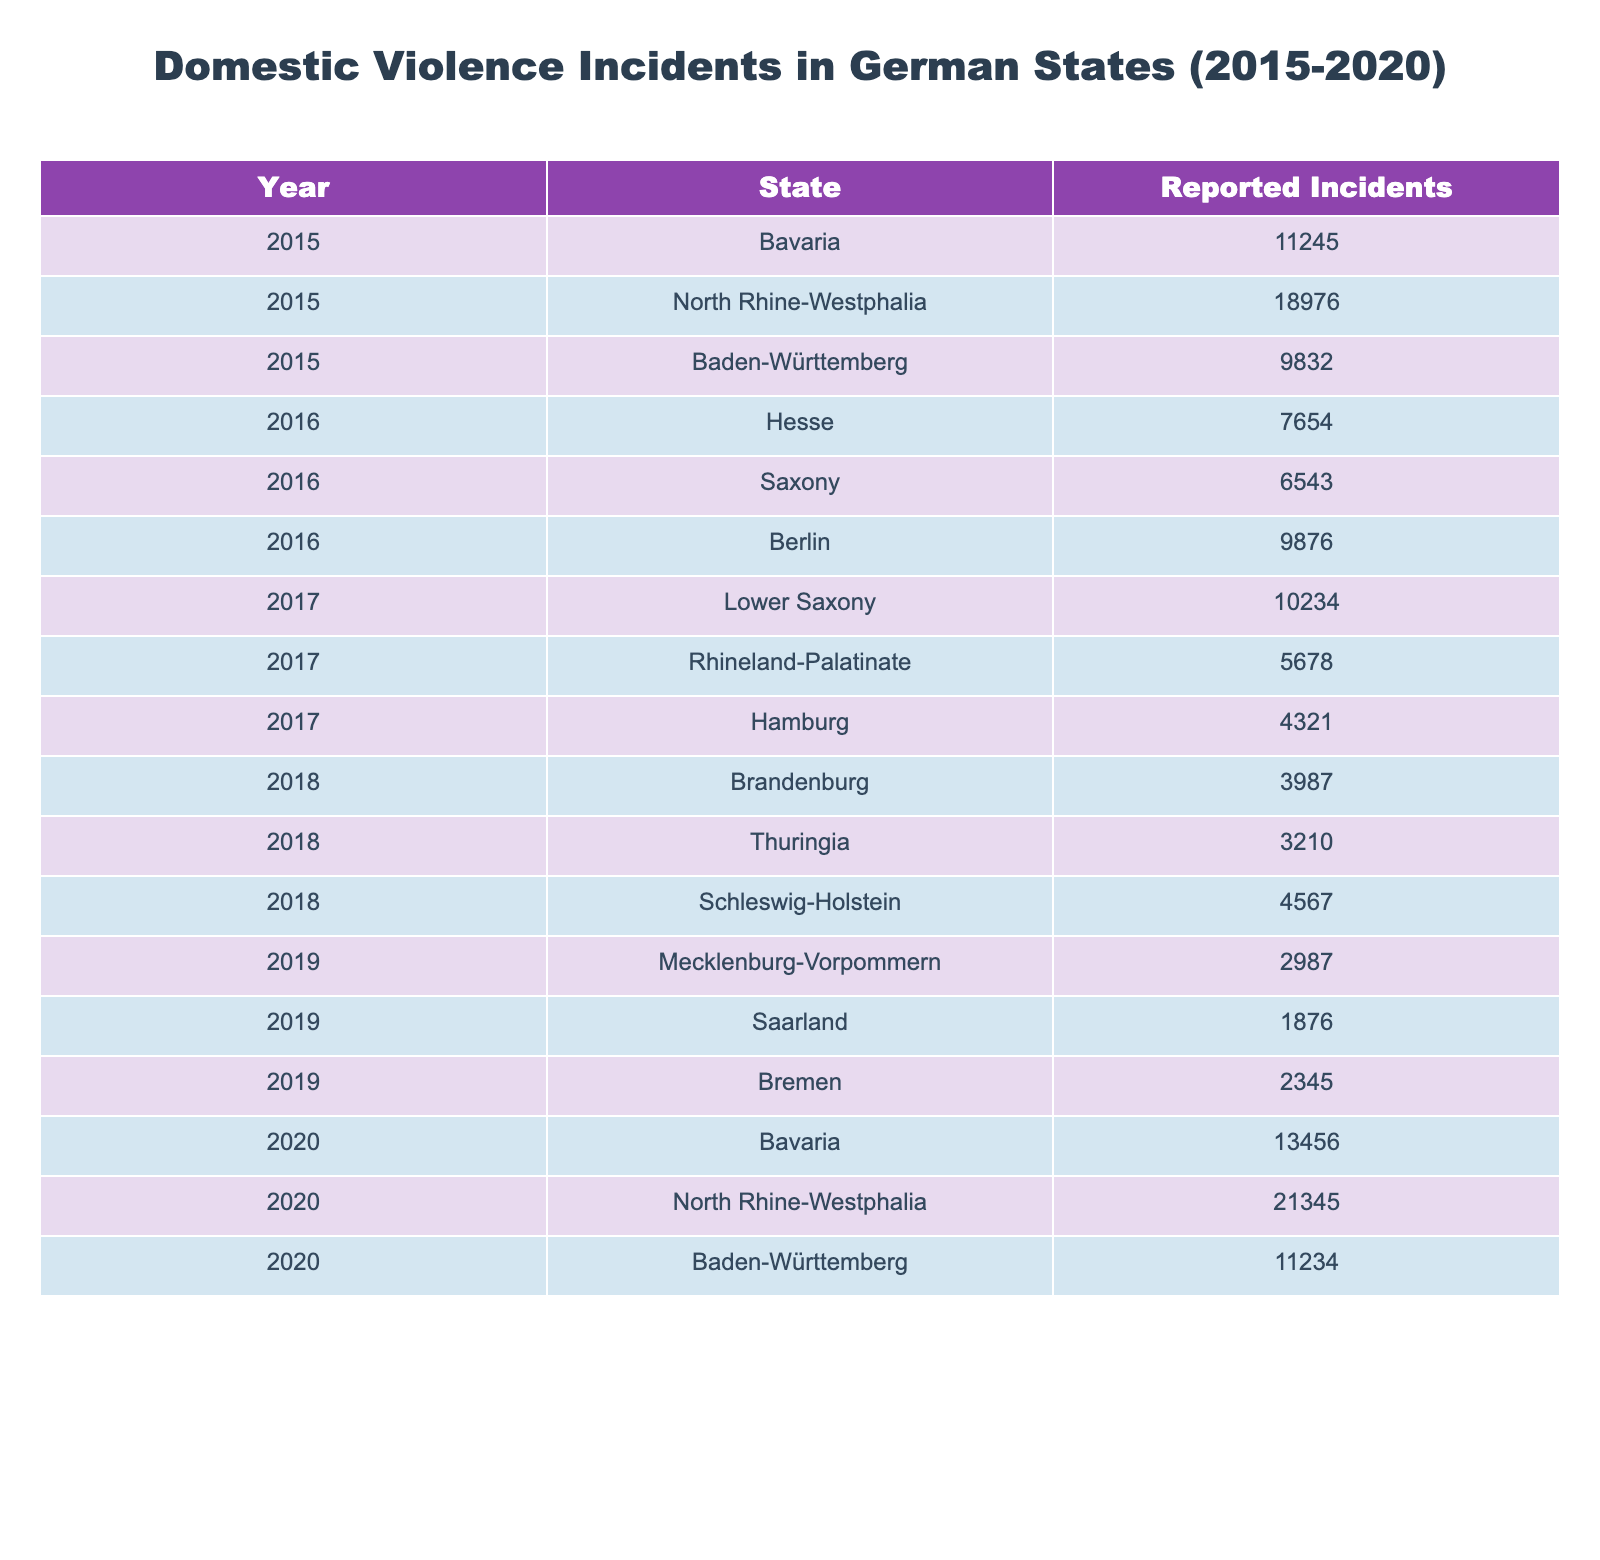What state had the highest reported incidents in 2020? In 2020, North Rhine-Westphalia had the highest number of reported incidents, with 21,345 incidents listed in the table.
Answer: North Rhine-Westphalia How many reported incidents were recorded in Bavaria in 2015 and 2020 combined? In 2015, Bavaria had 11,245 incidents and in 2020, it had 13,456 incidents. Combining these, we get 11,245 + 13,456 = 24,701.
Answer: 24,701 What is the average number of reported incidents across all states in 2016? The reported incidents in 2016 are: Hesse (7,654), Saxony (6,543), and Berlin (9,876). The sum is 7,654 + 6,543 + 9,876 = 24,073, and there are 3 states, so the average is 24,073 / 3 = 8,024.33, which rounds to approximately 8,024.
Answer: Approximately 8,024 Which state consistently reported incidents in all years from 2015 to 2020? The table shows that Bavaria reported incidents in both 2015 and 2020. All other states reported incidents in only select years, indicating they did not consistently report across all years.
Answer: Bavaria Did the number of reported incidents in 2019 exceed the total for 2015? The total reported incidents for 2015 is 11,245, while the sum for the states reporting in 2019 is 2,987 (Mecklenburg-Vorpommern) + 1,876 (Saarland) + 2,345 (Bremen) = 7,208. Since 7,208 is less than 11,245, the answer is no.
Answer: No What was the difference in reported incidents between North Rhine-Westphalia in 2020 and 2015? In 2015, North Rhine-Westphalia had 18,976 incidents, and in 2020, it had 21,345 incidents. The difference is 21,345 - 18,976 = 2,369.
Answer: 2,369 Which year showed a decline in reported incidents in any state compared to the previous year? By reviewing the table, 2018 shows a decline in incidents reported in Brandenburg (3,987) compared to 2017 in Lower Saxony (10,234), hence suggesting a decline pattern there.
Answer: 2018 What is the total number of reported incidents in Baden-Württemberg over the years available? The reported incidents for Baden-Württemberg are 9,832 in 2015 and 11,234 in 2020. Thus, the total is 9,832 + 11,234 = 21,066.
Answer: 21,066 Is it true that there were more reported incidents in 2017 than in 2018? In 2017, the incidents totaled: 10,234 (Lower Saxony) + 5,678 (Rhineland-Palatinate) + 4,321 (Hamburg) = 20,233. In 2018, the incidents totaled: 3,987 (Brandenburg) + 3,210 (Thuringia) + 4,567 (Schleswig-Holstein) = 11,764. Since 20,233 is greater than 11,764, the statement is true.
Answer: Yes What trend can be observed in domestic violence reports from 2015 to 2020 in the states listed? By comparing the years in the table, we observe an overall increasing trend in incidents reported from 2015 through 2020, particularly in North Rhine-Westphalia and Bavaria.
Answer: Increasing trend 